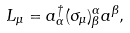<formula> <loc_0><loc_0><loc_500><loc_500>L _ { \mu } = a _ { \alpha } ^ { \dag } ( \sigma _ { \mu } ) ^ { \alpha } _ { \beta } a ^ { \beta } ,</formula> 